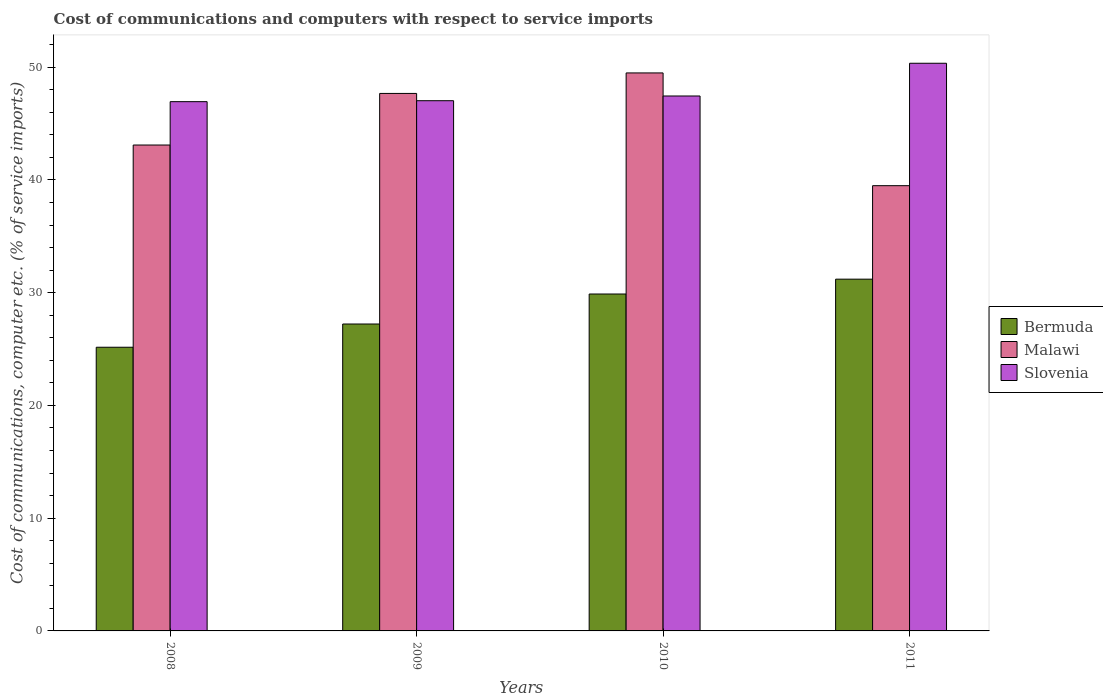How many groups of bars are there?
Provide a succinct answer. 4. Are the number of bars per tick equal to the number of legend labels?
Your response must be concise. Yes. How many bars are there on the 4th tick from the left?
Provide a succinct answer. 3. What is the label of the 4th group of bars from the left?
Give a very brief answer. 2011. In how many cases, is the number of bars for a given year not equal to the number of legend labels?
Offer a terse response. 0. What is the cost of communications and computers in Malawi in 2010?
Offer a terse response. 49.5. Across all years, what is the maximum cost of communications and computers in Bermuda?
Your answer should be very brief. 31.2. Across all years, what is the minimum cost of communications and computers in Slovenia?
Provide a short and direct response. 46.95. In which year was the cost of communications and computers in Bermuda maximum?
Offer a very short reply. 2011. In which year was the cost of communications and computers in Bermuda minimum?
Your answer should be compact. 2008. What is the total cost of communications and computers in Slovenia in the graph?
Provide a succinct answer. 191.78. What is the difference between the cost of communications and computers in Bermuda in 2008 and that in 2010?
Offer a terse response. -4.72. What is the difference between the cost of communications and computers in Slovenia in 2008 and the cost of communications and computers in Bermuda in 2011?
Give a very brief answer. 15.75. What is the average cost of communications and computers in Malawi per year?
Provide a succinct answer. 44.94. In the year 2011, what is the difference between the cost of communications and computers in Bermuda and cost of communications and computers in Slovenia?
Provide a succinct answer. -19.15. In how many years, is the cost of communications and computers in Slovenia greater than 8 %?
Give a very brief answer. 4. What is the ratio of the cost of communications and computers in Bermuda in 2008 to that in 2010?
Your answer should be very brief. 0.84. Is the cost of communications and computers in Bermuda in 2008 less than that in 2009?
Ensure brevity in your answer.  Yes. Is the difference between the cost of communications and computers in Bermuda in 2009 and 2011 greater than the difference between the cost of communications and computers in Slovenia in 2009 and 2011?
Provide a succinct answer. No. What is the difference between the highest and the second highest cost of communications and computers in Slovenia?
Your response must be concise. 2.9. What is the difference between the highest and the lowest cost of communications and computers in Slovenia?
Your answer should be very brief. 3.41. What does the 3rd bar from the left in 2009 represents?
Provide a short and direct response. Slovenia. What does the 2nd bar from the right in 2011 represents?
Provide a succinct answer. Malawi. How many bars are there?
Offer a terse response. 12. How many years are there in the graph?
Your response must be concise. 4. What is the difference between two consecutive major ticks on the Y-axis?
Your response must be concise. 10. Where does the legend appear in the graph?
Provide a short and direct response. Center right. What is the title of the graph?
Provide a succinct answer. Cost of communications and computers with respect to service imports. What is the label or title of the X-axis?
Offer a very short reply. Years. What is the label or title of the Y-axis?
Keep it short and to the point. Cost of communications, computer etc. (% of service imports). What is the Cost of communications, computer etc. (% of service imports) in Bermuda in 2008?
Make the answer very short. 25.16. What is the Cost of communications, computer etc. (% of service imports) in Malawi in 2008?
Offer a terse response. 43.1. What is the Cost of communications, computer etc. (% of service imports) of Slovenia in 2008?
Your answer should be very brief. 46.95. What is the Cost of communications, computer etc. (% of service imports) of Bermuda in 2009?
Give a very brief answer. 27.22. What is the Cost of communications, computer etc. (% of service imports) of Malawi in 2009?
Provide a short and direct response. 47.68. What is the Cost of communications, computer etc. (% of service imports) of Slovenia in 2009?
Offer a terse response. 47.03. What is the Cost of communications, computer etc. (% of service imports) of Bermuda in 2010?
Your answer should be compact. 29.89. What is the Cost of communications, computer etc. (% of service imports) of Malawi in 2010?
Make the answer very short. 49.5. What is the Cost of communications, computer etc. (% of service imports) in Slovenia in 2010?
Provide a short and direct response. 47.45. What is the Cost of communications, computer etc. (% of service imports) of Bermuda in 2011?
Offer a very short reply. 31.2. What is the Cost of communications, computer etc. (% of service imports) in Malawi in 2011?
Give a very brief answer. 39.49. What is the Cost of communications, computer etc. (% of service imports) in Slovenia in 2011?
Provide a succinct answer. 50.35. Across all years, what is the maximum Cost of communications, computer etc. (% of service imports) of Bermuda?
Your answer should be very brief. 31.2. Across all years, what is the maximum Cost of communications, computer etc. (% of service imports) of Malawi?
Your answer should be very brief. 49.5. Across all years, what is the maximum Cost of communications, computer etc. (% of service imports) in Slovenia?
Ensure brevity in your answer.  50.35. Across all years, what is the minimum Cost of communications, computer etc. (% of service imports) of Bermuda?
Keep it short and to the point. 25.16. Across all years, what is the minimum Cost of communications, computer etc. (% of service imports) of Malawi?
Your answer should be compact. 39.49. Across all years, what is the minimum Cost of communications, computer etc. (% of service imports) in Slovenia?
Ensure brevity in your answer.  46.95. What is the total Cost of communications, computer etc. (% of service imports) of Bermuda in the graph?
Keep it short and to the point. 113.48. What is the total Cost of communications, computer etc. (% of service imports) in Malawi in the graph?
Offer a terse response. 179.77. What is the total Cost of communications, computer etc. (% of service imports) of Slovenia in the graph?
Your answer should be compact. 191.78. What is the difference between the Cost of communications, computer etc. (% of service imports) in Bermuda in 2008 and that in 2009?
Provide a short and direct response. -2.06. What is the difference between the Cost of communications, computer etc. (% of service imports) in Malawi in 2008 and that in 2009?
Your response must be concise. -4.58. What is the difference between the Cost of communications, computer etc. (% of service imports) in Slovenia in 2008 and that in 2009?
Provide a short and direct response. -0.08. What is the difference between the Cost of communications, computer etc. (% of service imports) of Bermuda in 2008 and that in 2010?
Your response must be concise. -4.72. What is the difference between the Cost of communications, computer etc. (% of service imports) of Malawi in 2008 and that in 2010?
Provide a succinct answer. -6.4. What is the difference between the Cost of communications, computer etc. (% of service imports) in Slovenia in 2008 and that in 2010?
Ensure brevity in your answer.  -0.5. What is the difference between the Cost of communications, computer etc. (% of service imports) of Bermuda in 2008 and that in 2011?
Keep it short and to the point. -6.04. What is the difference between the Cost of communications, computer etc. (% of service imports) of Malawi in 2008 and that in 2011?
Provide a short and direct response. 3.61. What is the difference between the Cost of communications, computer etc. (% of service imports) of Slovenia in 2008 and that in 2011?
Keep it short and to the point. -3.41. What is the difference between the Cost of communications, computer etc. (% of service imports) of Bermuda in 2009 and that in 2010?
Keep it short and to the point. -2.66. What is the difference between the Cost of communications, computer etc. (% of service imports) in Malawi in 2009 and that in 2010?
Ensure brevity in your answer.  -1.82. What is the difference between the Cost of communications, computer etc. (% of service imports) of Slovenia in 2009 and that in 2010?
Your answer should be compact. -0.42. What is the difference between the Cost of communications, computer etc. (% of service imports) in Bermuda in 2009 and that in 2011?
Make the answer very short. -3.98. What is the difference between the Cost of communications, computer etc. (% of service imports) of Malawi in 2009 and that in 2011?
Make the answer very short. 8.18. What is the difference between the Cost of communications, computer etc. (% of service imports) of Slovenia in 2009 and that in 2011?
Your answer should be very brief. -3.32. What is the difference between the Cost of communications, computer etc. (% of service imports) of Bermuda in 2010 and that in 2011?
Provide a succinct answer. -1.32. What is the difference between the Cost of communications, computer etc. (% of service imports) of Malawi in 2010 and that in 2011?
Ensure brevity in your answer.  10. What is the difference between the Cost of communications, computer etc. (% of service imports) in Slovenia in 2010 and that in 2011?
Provide a succinct answer. -2.9. What is the difference between the Cost of communications, computer etc. (% of service imports) of Bermuda in 2008 and the Cost of communications, computer etc. (% of service imports) of Malawi in 2009?
Offer a terse response. -22.51. What is the difference between the Cost of communications, computer etc. (% of service imports) in Bermuda in 2008 and the Cost of communications, computer etc. (% of service imports) in Slovenia in 2009?
Keep it short and to the point. -21.87. What is the difference between the Cost of communications, computer etc. (% of service imports) of Malawi in 2008 and the Cost of communications, computer etc. (% of service imports) of Slovenia in 2009?
Give a very brief answer. -3.93. What is the difference between the Cost of communications, computer etc. (% of service imports) in Bermuda in 2008 and the Cost of communications, computer etc. (% of service imports) in Malawi in 2010?
Your response must be concise. -24.33. What is the difference between the Cost of communications, computer etc. (% of service imports) of Bermuda in 2008 and the Cost of communications, computer etc. (% of service imports) of Slovenia in 2010?
Offer a very short reply. -22.29. What is the difference between the Cost of communications, computer etc. (% of service imports) in Malawi in 2008 and the Cost of communications, computer etc. (% of service imports) in Slovenia in 2010?
Ensure brevity in your answer.  -4.35. What is the difference between the Cost of communications, computer etc. (% of service imports) of Bermuda in 2008 and the Cost of communications, computer etc. (% of service imports) of Malawi in 2011?
Provide a short and direct response. -14.33. What is the difference between the Cost of communications, computer etc. (% of service imports) of Bermuda in 2008 and the Cost of communications, computer etc. (% of service imports) of Slovenia in 2011?
Keep it short and to the point. -25.19. What is the difference between the Cost of communications, computer etc. (% of service imports) of Malawi in 2008 and the Cost of communications, computer etc. (% of service imports) of Slovenia in 2011?
Your answer should be compact. -7.25. What is the difference between the Cost of communications, computer etc. (% of service imports) in Bermuda in 2009 and the Cost of communications, computer etc. (% of service imports) in Malawi in 2010?
Make the answer very short. -22.27. What is the difference between the Cost of communications, computer etc. (% of service imports) in Bermuda in 2009 and the Cost of communications, computer etc. (% of service imports) in Slovenia in 2010?
Give a very brief answer. -20.23. What is the difference between the Cost of communications, computer etc. (% of service imports) of Malawi in 2009 and the Cost of communications, computer etc. (% of service imports) of Slovenia in 2010?
Make the answer very short. 0.23. What is the difference between the Cost of communications, computer etc. (% of service imports) of Bermuda in 2009 and the Cost of communications, computer etc. (% of service imports) of Malawi in 2011?
Offer a terse response. -12.27. What is the difference between the Cost of communications, computer etc. (% of service imports) of Bermuda in 2009 and the Cost of communications, computer etc. (% of service imports) of Slovenia in 2011?
Make the answer very short. -23.13. What is the difference between the Cost of communications, computer etc. (% of service imports) of Malawi in 2009 and the Cost of communications, computer etc. (% of service imports) of Slovenia in 2011?
Provide a succinct answer. -2.68. What is the difference between the Cost of communications, computer etc. (% of service imports) in Bermuda in 2010 and the Cost of communications, computer etc. (% of service imports) in Malawi in 2011?
Your response must be concise. -9.61. What is the difference between the Cost of communications, computer etc. (% of service imports) of Bermuda in 2010 and the Cost of communications, computer etc. (% of service imports) of Slovenia in 2011?
Your answer should be compact. -20.47. What is the difference between the Cost of communications, computer etc. (% of service imports) in Malawi in 2010 and the Cost of communications, computer etc. (% of service imports) in Slovenia in 2011?
Your answer should be compact. -0.86. What is the average Cost of communications, computer etc. (% of service imports) in Bermuda per year?
Offer a terse response. 28.37. What is the average Cost of communications, computer etc. (% of service imports) of Malawi per year?
Keep it short and to the point. 44.94. What is the average Cost of communications, computer etc. (% of service imports) in Slovenia per year?
Ensure brevity in your answer.  47.95. In the year 2008, what is the difference between the Cost of communications, computer etc. (% of service imports) of Bermuda and Cost of communications, computer etc. (% of service imports) of Malawi?
Offer a very short reply. -17.94. In the year 2008, what is the difference between the Cost of communications, computer etc. (% of service imports) in Bermuda and Cost of communications, computer etc. (% of service imports) in Slovenia?
Ensure brevity in your answer.  -21.78. In the year 2008, what is the difference between the Cost of communications, computer etc. (% of service imports) of Malawi and Cost of communications, computer etc. (% of service imports) of Slovenia?
Provide a short and direct response. -3.85. In the year 2009, what is the difference between the Cost of communications, computer etc. (% of service imports) in Bermuda and Cost of communications, computer etc. (% of service imports) in Malawi?
Make the answer very short. -20.45. In the year 2009, what is the difference between the Cost of communications, computer etc. (% of service imports) in Bermuda and Cost of communications, computer etc. (% of service imports) in Slovenia?
Keep it short and to the point. -19.81. In the year 2009, what is the difference between the Cost of communications, computer etc. (% of service imports) of Malawi and Cost of communications, computer etc. (% of service imports) of Slovenia?
Provide a succinct answer. 0.64. In the year 2010, what is the difference between the Cost of communications, computer etc. (% of service imports) in Bermuda and Cost of communications, computer etc. (% of service imports) in Malawi?
Your response must be concise. -19.61. In the year 2010, what is the difference between the Cost of communications, computer etc. (% of service imports) in Bermuda and Cost of communications, computer etc. (% of service imports) in Slovenia?
Offer a terse response. -17.56. In the year 2010, what is the difference between the Cost of communications, computer etc. (% of service imports) in Malawi and Cost of communications, computer etc. (% of service imports) in Slovenia?
Your answer should be compact. 2.05. In the year 2011, what is the difference between the Cost of communications, computer etc. (% of service imports) in Bermuda and Cost of communications, computer etc. (% of service imports) in Malawi?
Your response must be concise. -8.29. In the year 2011, what is the difference between the Cost of communications, computer etc. (% of service imports) in Bermuda and Cost of communications, computer etc. (% of service imports) in Slovenia?
Offer a terse response. -19.15. In the year 2011, what is the difference between the Cost of communications, computer etc. (% of service imports) in Malawi and Cost of communications, computer etc. (% of service imports) in Slovenia?
Your answer should be very brief. -10.86. What is the ratio of the Cost of communications, computer etc. (% of service imports) in Bermuda in 2008 to that in 2009?
Provide a short and direct response. 0.92. What is the ratio of the Cost of communications, computer etc. (% of service imports) in Malawi in 2008 to that in 2009?
Provide a succinct answer. 0.9. What is the ratio of the Cost of communications, computer etc. (% of service imports) in Slovenia in 2008 to that in 2009?
Provide a succinct answer. 1. What is the ratio of the Cost of communications, computer etc. (% of service imports) of Bermuda in 2008 to that in 2010?
Ensure brevity in your answer.  0.84. What is the ratio of the Cost of communications, computer etc. (% of service imports) of Malawi in 2008 to that in 2010?
Your response must be concise. 0.87. What is the ratio of the Cost of communications, computer etc. (% of service imports) of Slovenia in 2008 to that in 2010?
Keep it short and to the point. 0.99. What is the ratio of the Cost of communications, computer etc. (% of service imports) in Bermuda in 2008 to that in 2011?
Keep it short and to the point. 0.81. What is the ratio of the Cost of communications, computer etc. (% of service imports) in Malawi in 2008 to that in 2011?
Ensure brevity in your answer.  1.09. What is the ratio of the Cost of communications, computer etc. (% of service imports) in Slovenia in 2008 to that in 2011?
Keep it short and to the point. 0.93. What is the ratio of the Cost of communications, computer etc. (% of service imports) of Bermuda in 2009 to that in 2010?
Ensure brevity in your answer.  0.91. What is the ratio of the Cost of communications, computer etc. (% of service imports) in Malawi in 2009 to that in 2010?
Your answer should be compact. 0.96. What is the ratio of the Cost of communications, computer etc. (% of service imports) in Bermuda in 2009 to that in 2011?
Give a very brief answer. 0.87. What is the ratio of the Cost of communications, computer etc. (% of service imports) of Malawi in 2009 to that in 2011?
Your answer should be compact. 1.21. What is the ratio of the Cost of communications, computer etc. (% of service imports) of Slovenia in 2009 to that in 2011?
Offer a very short reply. 0.93. What is the ratio of the Cost of communications, computer etc. (% of service imports) in Bermuda in 2010 to that in 2011?
Provide a short and direct response. 0.96. What is the ratio of the Cost of communications, computer etc. (% of service imports) of Malawi in 2010 to that in 2011?
Ensure brevity in your answer.  1.25. What is the ratio of the Cost of communications, computer etc. (% of service imports) of Slovenia in 2010 to that in 2011?
Provide a succinct answer. 0.94. What is the difference between the highest and the second highest Cost of communications, computer etc. (% of service imports) of Bermuda?
Offer a terse response. 1.32. What is the difference between the highest and the second highest Cost of communications, computer etc. (% of service imports) of Malawi?
Give a very brief answer. 1.82. What is the difference between the highest and the second highest Cost of communications, computer etc. (% of service imports) of Slovenia?
Make the answer very short. 2.9. What is the difference between the highest and the lowest Cost of communications, computer etc. (% of service imports) in Bermuda?
Ensure brevity in your answer.  6.04. What is the difference between the highest and the lowest Cost of communications, computer etc. (% of service imports) of Malawi?
Provide a succinct answer. 10. What is the difference between the highest and the lowest Cost of communications, computer etc. (% of service imports) of Slovenia?
Offer a very short reply. 3.41. 